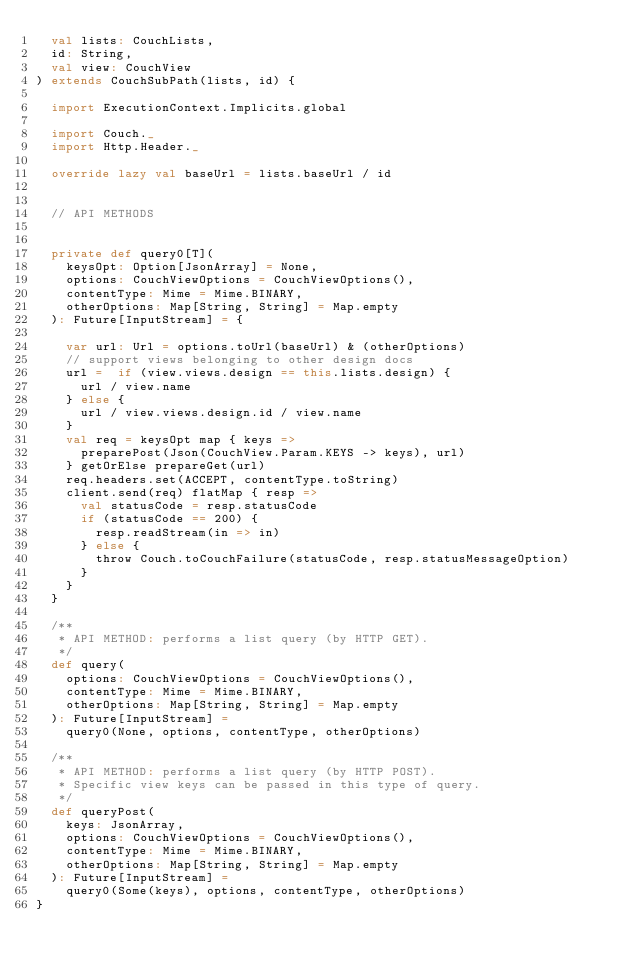Convert code to text. <code><loc_0><loc_0><loc_500><loc_500><_Scala_>  val lists: CouchLists,
  id: String,
  val view: CouchView
) extends CouchSubPath(lists, id) {
  
  import ExecutionContext.Implicits.global
  
  import Couch._
  import Http.Header._
  
  override lazy val baseUrl = lists.baseUrl / id
  
  
  // API METHODS
  
  
  private def query0[T](
    keysOpt: Option[JsonArray] = None,
    options: CouchViewOptions = CouchViewOptions(),
    contentType: Mime = Mime.BINARY,
    otherOptions: Map[String, String] = Map.empty
  ): Future[InputStream] = {
    
    var url: Url = options.toUrl(baseUrl) & (otherOptions)
    // support views belonging to other design docs
    url =  if (view.views.design == this.lists.design) {
      url / view.name
    } else {
      url / view.views.design.id / view.name
    }
    val req = keysOpt map { keys =>
      preparePost(Json(CouchView.Param.KEYS -> keys), url)
    } getOrElse prepareGet(url)
    req.headers.set(ACCEPT, contentType.toString)
    client.send(req) flatMap { resp =>
      val statusCode = resp.statusCode
      if (statusCode == 200) {
        resp.readStream(in => in)
      } else {
        throw Couch.toCouchFailure(statusCode, resp.statusMessageOption)
      }
    }
  }
  
  /**
   * API METHOD: performs a list query (by HTTP GET).
   */
  def query(
    options: CouchViewOptions = CouchViewOptions(),
    contentType: Mime = Mime.BINARY,
    otherOptions: Map[String, String] = Map.empty
  ): Future[InputStream] = 
    query0(None, options, contentType, otherOptions)
  
  /**
   * API METHOD: performs a list query (by HTTP POST).
   * Specific view keys can be passed in this type of query.
   */
  def queryPost(
    keys: JsonArray,
    options: CouchViewOptions = CouchViewOptions(),
    contentType: Mime = Mime.BINARY,
    otherOptions: Map[String, String] = Map.empty
  ): Future[InputStream] = 
    query0(Some(keys), options, contentType, otherOptions)
}
</code> 